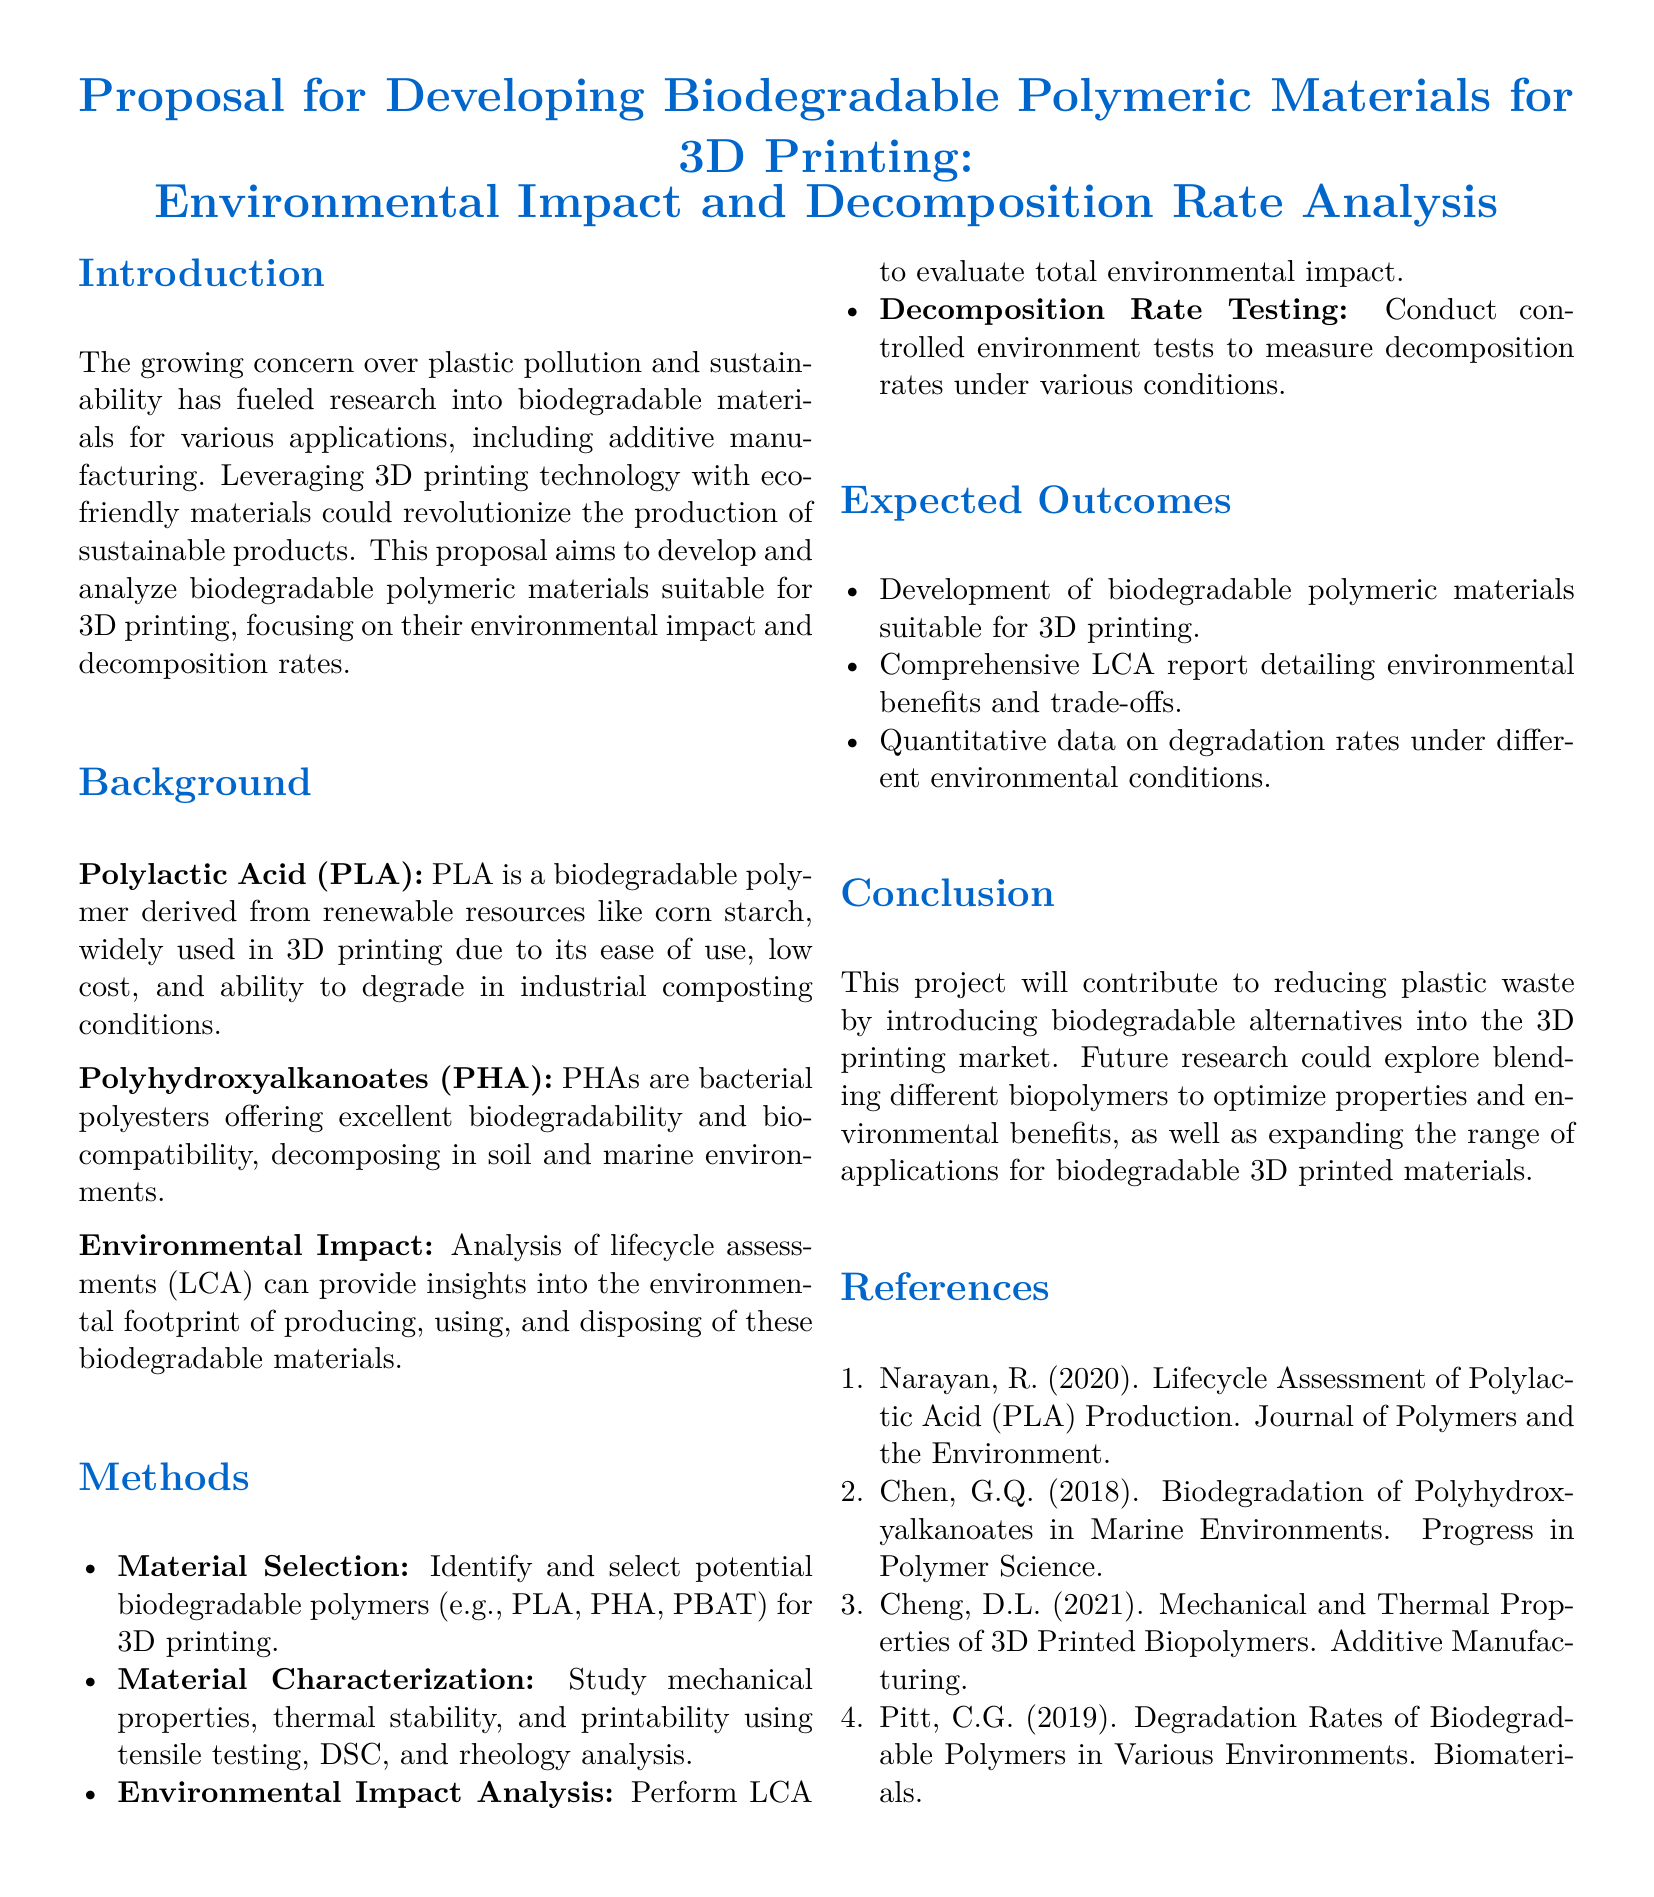What is the focus of the proposal? The proposal focuses on developing and analyzing biodegradable polymeric materials for 3D printing, emphasizing environmental impact and decomposition rates.
Answer: biodegradable polymeric materials for 3D printing What are the two biodegradable polymers mentioned in the background? The background mentions two polymers, Polylactic Acid and Polyhydroxyalkanoates.
Answer: Polylactic Acid and Polyhydroxyalkanoates What kind of tests will be conducted to measure decomposition rates? The proposal outlines that controlled environment tests will be conducted to measure decomposition rates under various conditions.
Answer: controlled environment tests How many environmental impact analyses are planned? The proposal states that one comprehensive lifecycle assessment (LCA) will be performed to evaluate total environmental impact.
Answer: one What is one expected outcome of the study? The expected outcomes include the development of biodegradable polymeric materials suitable for 3D printing.
Answer: biodegradable polymeric materials suitable for 3D printing What does LCA stand for? In the document, LCA stands for lifecycle assessment.
Answer: lifecycle assessment Which journal is referenced for the lifecycle assessment of Polylactic Acid production? The proposal references the Journal of Polymers and the Environment for information on the lifecycle assessment of Polylactic Acid.
Answer: Journal of Polymers and the Environment What is an aim of future research mentioned in the proposal? The proposal mentions exploring blending different biopolymers to optimize properties and environmental benefits as an aim of future research.
Answer: blending different biopolymers 